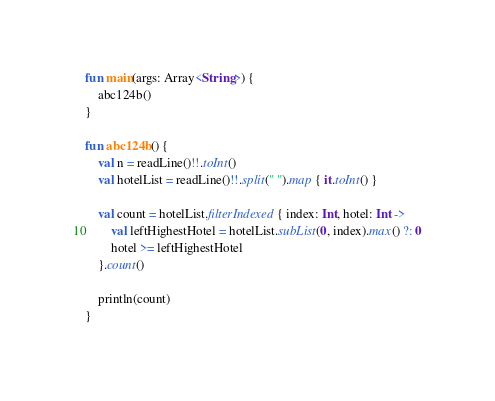<code> <loc_0><loc_0><loc_500><loc_500><_Kotlin_>fun main(args: Array<String>) {
    abc124b()
}

fun abc124b() {
    val n = readLine()!!.toInt()
    val hotelList = readLine()!!.split(" ").map { it.toInt() }

    val count = hotelList.filterIndexed { index: Int, hotel: Int ->
        val leftHighestHotel = hotelList.subList(0, index).max() ?: 0
        hotel >= leftHighestHotel
    }.count()

    println(count)
}

</code> 